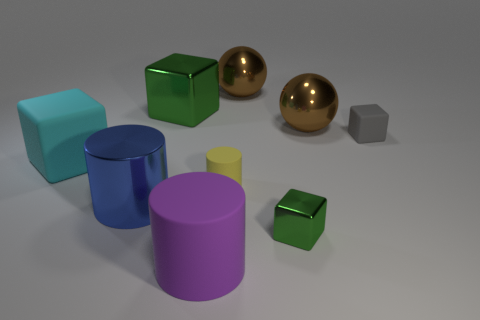Add 1 big blue balls. How many objects exist? 10 Subtract all balls. How many objects are left? 7 Subtract all small purple metallic spheres. Subtract all small things. How many objects are left? 6 Add 7 big green shiny things. How many big green shiny things are left? 8 Add 3 tiny shiny objects. How many tiny shiny objects exist? 4 Subtract 0 brown cylinders. How many objects are left? 9 